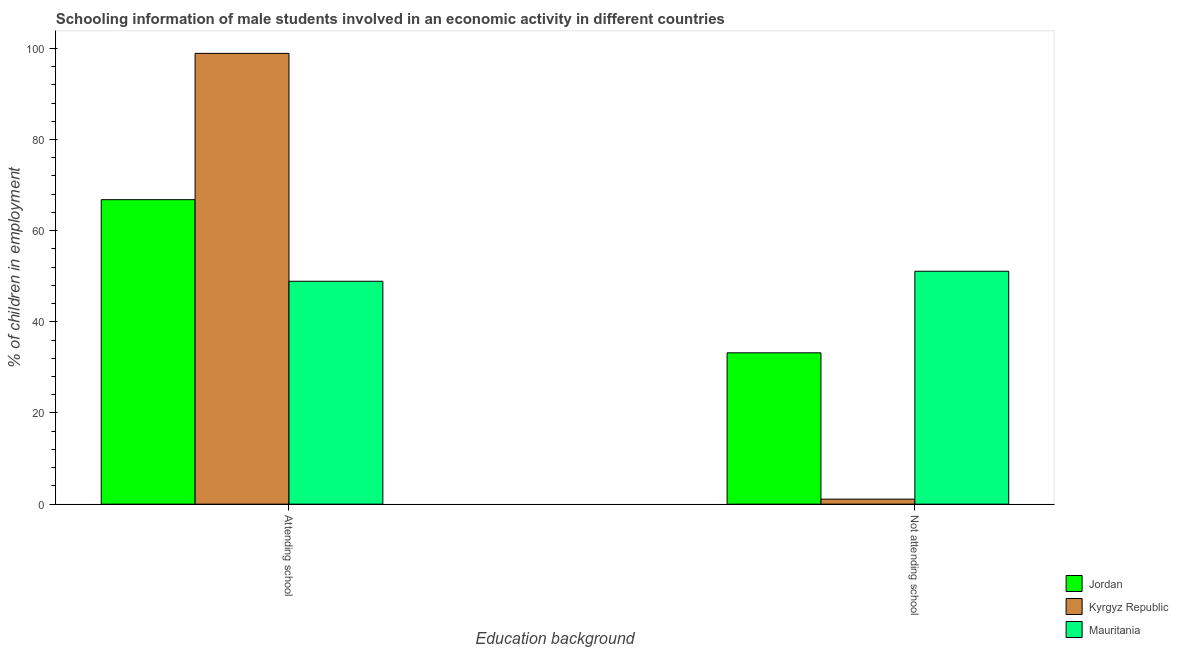How many different coloured bars are there?
Your response must be concise. 3. Are the number of bars on each tick of the X-axis equal?
Provide a succinct answer. Yes. How many bars are there on the 2nd tick from the left?
Provide a succinct answer. 3. What is the label of the 2nd group of bars from the left?
Keep it short and to the point. Not attending school. What is the percentage of employed males who are not attending school in Kyrgyz Republic?
Provide a short and direct response. 1.1. Across all countries, what is the maximum percentage of employed males who are not attending school?
Provide a short and direct response. 51.1. Across all countries, what is the minimum percentage of employed males who are attending school?
Provide a short and direct response. 48.9. In which country was the percentage of employed males who are not attending school maximum?
Make the answer very short. Mauritania. In which country was the percentage of employed males who are attending school minimum?
Offer a very short reply. Mauritania. What is the total percentage of employed males who are not attending school in the graph?
Offer a terse response. 85.4. What is the difference between the percentage of employed males who are not attending school in Kyrgyz Republic and that in Jordan?
Ensure brevity in your answer.  -32.1. What is the difference between the percentage of employed males who are attending school in Jordan and the percentage of employed males who are not attending school in Kyrgyz Republic?
Offer a very short reply. 65.7. What is the average percentage of employed males who are attending school per country?
Provide a succinct answer. 71.53. What is the difference between the percentage of employed males who are not attending school and percentage of employed males who are attending school in Jordan?
Provide a succinct answer. -33.6. In how many countries, is the percentage of employed males who are attending school greater than 20 %?
Provide a succinct answer. 3. What is the ratio of the percentage of employed males who are attending school in Jordan to that in Mauritania?
Provide a succinct answer. 1.37. What does the 2nd bar from the left in Not attending school represents?
Give a very brief answer. Kyrgyz Republic. What does the 2nd bar from the right in Not attending school represents?
Make the answer very short. Kyrgyz Republic. How many bars are there?
Keep it short and to the point. 6. Are all the bars in the graph horizontal?
Offer a very short reply. No. What is the difference between two consecutive major ticks on the Y-axis?
Your answer should be very brief. 20. Where does the legend appear in the graph?
Offer a very short reply. Bottom right. How are the legend labels stacked?
Offer a very short reply. Vertical. What is the title of the graph?
Offer a terse response. Schooling information of male students involved in an economic activity in different countries. What is the label or title of the X-axis?
Keep it short and to the point. Education background. What is the label or title of the Y-axis?
Provide a short and direct response. % of children in employment. What is the % of children in employment in Jordan in Attending school?
Give a very brief answer. 66.8. What is the % of children in employment in Kyrgyz Republic in Attending school?
Provide a short and direct response. 98.9. What is the % of children in employment in Mauritania in Attending school?
Your response must be concise. 48.9. What is the % of children in employment in Jordan in Not attending school?
Keep it short and to the point. 33.2. What is the % of children in employment in Kyrgyz Republic in Not attending school?
Give a very brief answer. 1.1. What is the % of children in employment of Mauritania in Not attending school?
Provide a succinct answer. 51.1. Across all Education background, what is the maximum % of children in employment of Jordan?
Your answer should be compact. 66.8. Across all Education background, what is the maximum % of children in employment in Kyrgyz Republic?
Your answer should be very brief. 98.9. Across all Education background, what is the maximum % of children in employment of Mauritania?
Your response must be concise. 51.1. Across all Education background, what is the minimum % of children in employment in Jordan?
Your answer should be very brief. 33.2. Across all Education background, what is the minimum % of children in employment of Mauritania?
Your response must be concise. 48.9. What is the total % of children in employment of Jordan in the graph?
Your answer should be very brief. 100. What is the total % of children in employment of Mauritania in the graph?
Provide a succinct answer. 100. What is the difference between the % of children in employment of Jordan in Attending school and that in Not attending school?
Provide a succinct answer. 33.6. What is the difference between the % of children in employment in Kyrgyz Republic in Attending school and that in Not attending school?
Keep it short and to the point. 97.8. What is the difference between the % of children in employment in Jordan in Attending school and the % of children in employment in Kyrgyz Republic in Not attending school?
Ensure brevity in your answer.  65.7. What is the difference between the % of children in employment in Kyrgyz Republic in Attending school and the % of children in employment in Mauritania in Not attending school?
Provide a succinct answer. 47.8. What is the average % of children in employment of Jordan per Education background?
Offer a terse response. 50. What is the difference between the % of children in employment in Jordan and % of children in employment in Kyrgyz Republic in Attending school?
Offer a very short reply. -32.1. What is the difference between the % of children in employment in Kyrgyz Republic and % of children in employment in Mauritania in Attending school?
Ensure brevity in your answer.  50. What is the difference between the % of children in employment of Jordan and % of children in employment of Kyrgyz Republic in Not attending school?
Offer a very short reply. 32.1. What is the difference between the % of children in employment in Jordan and % of children in employment in Mauritania in Not attending school?
Your answer should be very brief. -17.9. What is the difference between the % of children in employment in Kyrgyz Republic and % of children in employment in Mauritania in Not attending school?
Your answer should be very brief. -50. What is the ratio of the % of children in employment of Jordan in Attending school to that in Not attending school?
Your answer should be compact. 2.01. What is the ratio of the % of children in employment of Kyrgyz Republic in Attending school to that in Not attending school?
Give a very brief answer. 89.91. What is the ratio of the % of children in employment of Mauritania in Attending school to that in Not attending school?
Your answer should be very brief. 0.96. What is the difference between the highest and the second highest % of children in employment of Jordan?
Keep it short and to the point. 33.6. What is the difference between the highest and the second highest % of children in employment in Kyrgyz Republic?
Make the answer very short. 97.8. What is the difference between the highest and the lowest % of children in employment of Jordan?
Give a very brief answer. 33.6. What is the difference between the highest and the lowest % of children in employment of Kyrgyz Republic?
Give a very brief answer. 97.8. What is the difference between the highest and the lowest % of children in employment in Mauritania?
Provide a succinct answer. 2.2. 